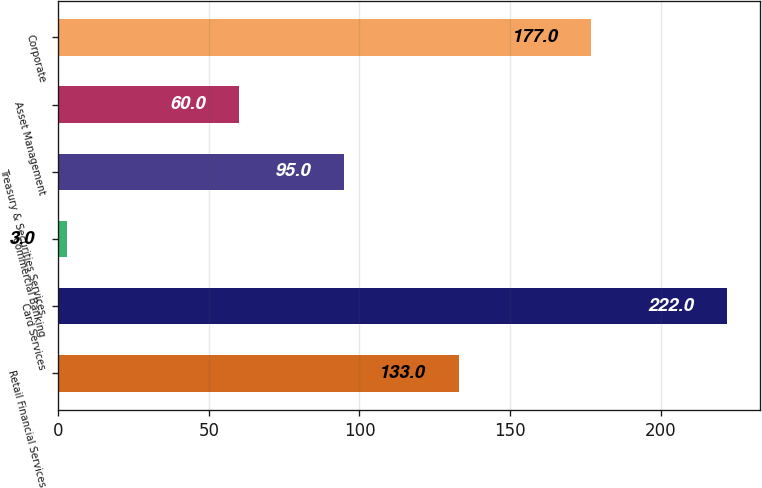Convert chart to OTSL. <chart><loc_0><loc_0><loc_500><loc_500><bar_chart><fcel>Retail Financial Services<fcel>Card Services<fcel>Commercial Banking<fcel>Treasury & Securities Services<fcel>Asset Management<fcel>Corporate<nl><fcel>133<fcel>222<fcel>3<fcel>95<fcel>60<fcel>177<nl></chart> 